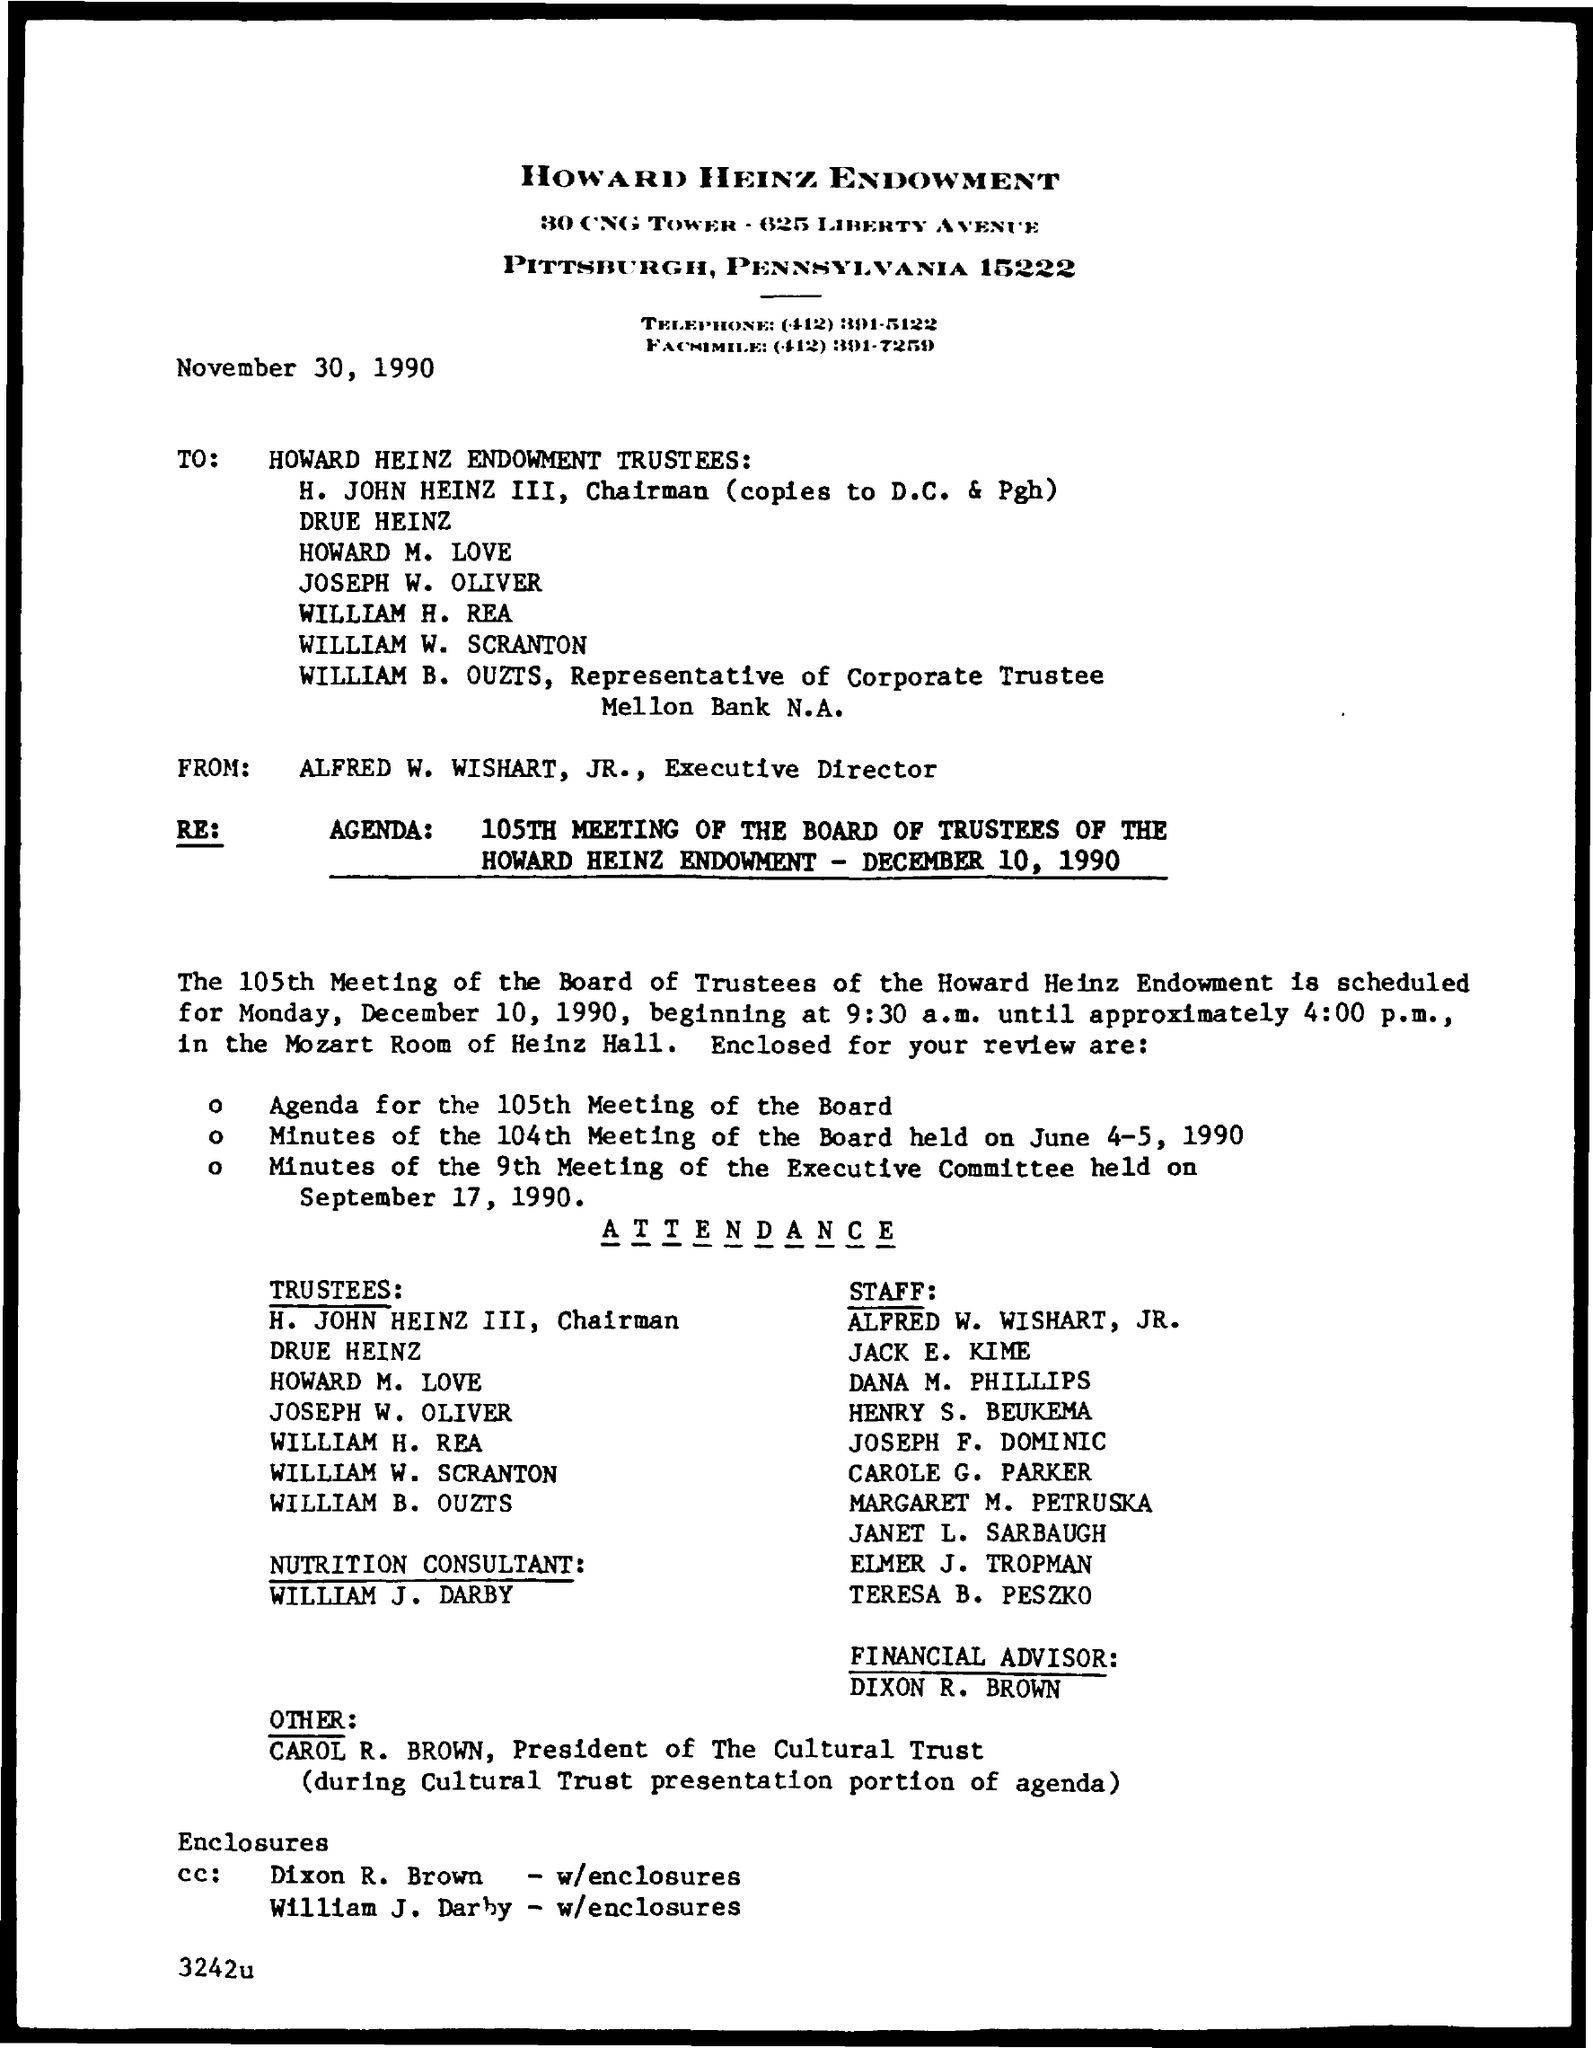Who is the chairman of the company
Offer a terse response. H. John Heinz III. 